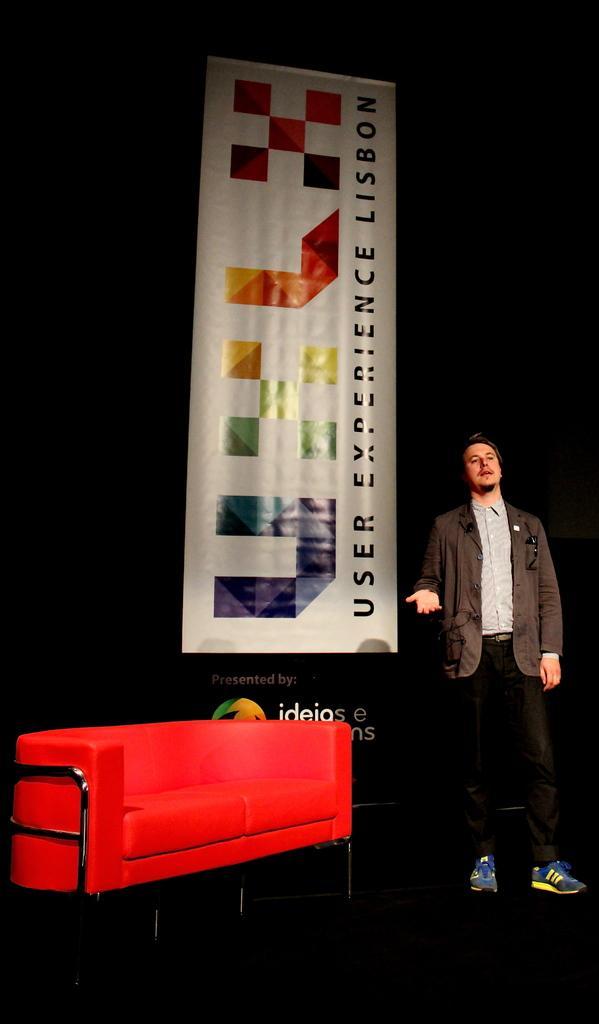Describe this image in one or two sentences. Here in this picture we can see a man standing on a stage and speaking something and beside him we can see a couch present and behind him we can see a banner present. 